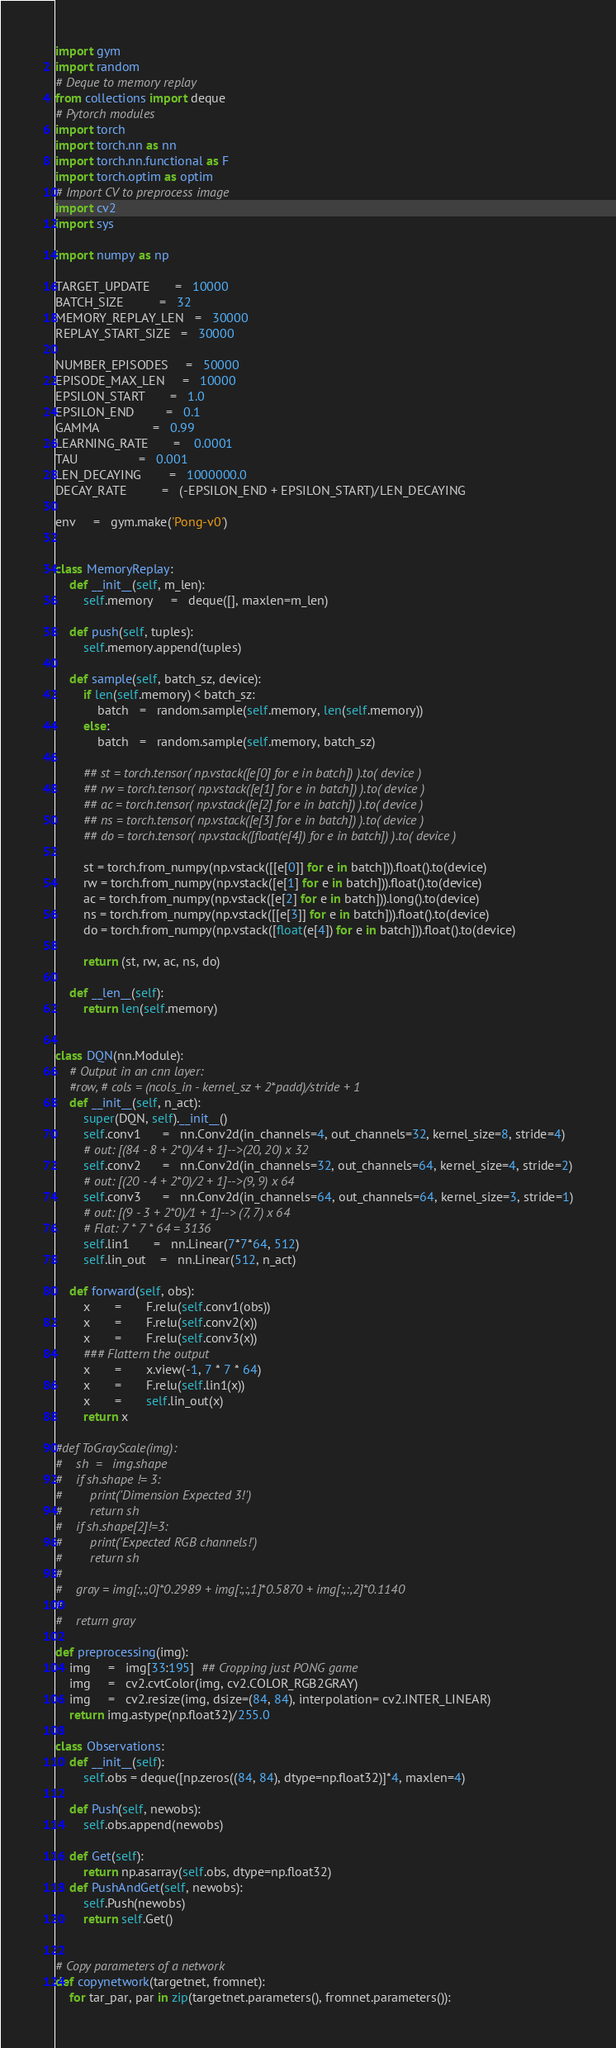Convert code to text. <code><loc_0><loc_0><loc_500><loc_500><_Python_>import gym
import random
# Deque to memory replay
from collections import deque
# Pytorch modules
import torch
import torch.nn as nn
import torch.nn.functional as F
import torch.optim as optim
# Import CV to preprocess image
import cv2
import sys

import numpy as np

TARGET_UPDATE       =   10000
BATCH_SIZE          =   32
MEMORY_REPLAY_LEN   =   30000
REPLAY_START_SIZE   =   30000

NUMBER_EPISODES     =   50000
EPISODE_MAX_LEN     =   10000
EPSILON_START       =   1.0
EPSILON_END         =   0.1
GAMMA               =   0.99
LEARNING_RATE       =	0.0001
TAU                 =   0.001
LEN_DECAYING        =   1000000.0
DECAY_RATE          =   (-EPSILON_END + EPSILON_START)/LEN_DECAYING

env     =   gym.make('Pong-v0')


class MemoryReplay:
    def __init__(self, m_len):
        self.memory     =   deque([], maxlen=m_len)

    def push(self, tuples):
        self.memory.append(tuples)

    def sample(self, batch_sz, device):
        if len(self.memory) < batch_sz:
            batch   =   random.sample(self.memory, len(self.memory))
        else:
            batch   =   random.sample(self.memory, batch_sz)

        ## st = torch.tensor( np.vstack([e[0] for e in batch]) ).to( device )
        ## rw = torch.tensor( np.vstack([e[1] for e in batch]) ).to( device )
        ## ac = torch.tensor( np.vstack([e[2] for e in batch]) ).to( device )
        ## ns = torch.tensor( np.vstack([e[3] for e in batch]) ).to( device )
        ## do = torch.tensor( np.vstack([float(e[4]) for e in batch]) ).to( device )

        st = torch.from_numpy(np.vstack([[e[0]] for e in batch])).float().to(device)
        rw = torch.from_numpy(np.vstack([e[1] for e in batch])).float().to(device)
        ac = torch.from_numpy(np.vstack([e[2] for e in batch])).long().to(device)
        ns = torch.from_numpy(np.vstack([[e[3]] for e in batch])).float().to(device)
        do = torch.from_numpy(np.vstack([float(e[4]) for e in batch])).float().to(device)

        return (st, rw, ac, ns, do)
    
    def __len__(self):
        return len(self.memory)


class DQN(nn.Module):
    # Output in an cnn layer:
    #row, # cols = (ncols_in - kernel_sz + 2*padd)/stride + 1
    def __init__(self, n_act):
        super(DQN, self).__init__()
        self.conv1      =   nn.Conv2d(in_channels=4, out_channels=32, kernel_size=8, stride=4)
        # out: [(84 - 8 + 2*0)/4 + 1]-->(20, 20) x 32
        self.conv2      =   nn.Conv2d(in_channels=32, out_channels=64, kernel_size=4, stride=2)
        # out: [(20 - 4 + 2*0)/2 + 1]-->(9, 9) x 64
        self.conv3      =   nn.Conv2d(in_channels=64, out_channels=64, kernel_size=3, stride=1)
        # out: [(9 - 3 + 2*0)/1 + 1]--> (7, 7) x 64
        # Flat: 7 * 7 * 64 = 3136
        self.lin1       =   nn.Linear(7*7*64, 512)
        self.lin_out    =   nn.Linear(512, n_act)

    def forward(self, obs):
        x       =       F.relu(self.conv1(obs))
        x       =       F.relu(self.conv2(x))
        x       =       F.relu(self.conv3(x))
        ### Flattern the output
        x       =       x.view(-1, 7 * 7 * 64)
        x       =       F.relu(self.lin1(x))
        x       =       self.lin_out(x)
        return x

#def ToGrayScale(img):
#    sh  =   img.shape
#    if sh.shape != 3:
#        print('Dimension Expected 3!')
#        return sh
#    if sh.shape[2]!=3:
#        print('Expected RGB channels!')
#        return sh
#    
#    gray = img[:,:,0]*0.2989 + img[:,:,1]*0.5870 + img[:,:,2]*0.1140
#
#    return gray

def preprocessing(img):
    img     =   img[33:195]  ## Cropping just PONG game
    img     =   cv2.cvtColor(img, cv2.COLOR_RGB2GRAY)
    img     =   cv2.resize(img, dsize=(84, 84), interpolation= cv2.INTER_LINEAR)
    return img.astype(np.float32)/255.0

class Observations:
    def __init__(self):
        self.obs = deque([np.zeros((84, 84), dtype=np.float32)]*4, maxlen=4)

    def Push(self, newobs):
        self.obs.append(newobs)
    
    def Get(self):
        return np.asarray(self.obs, dtype=np.float32)
    def PushAndGet(self, newobs):
        self.Push(newobs)
        return self.Get()


# Copy parameters of a network
def copynetwork(targetnet, fromnet):
    for tar_par, par in zip(targetnet.parameters(), fromnet.parameters()):</code> 